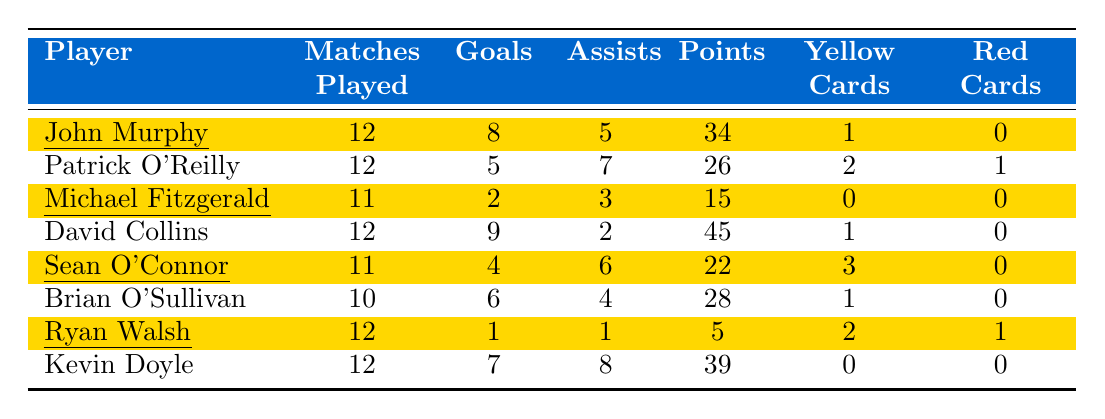What is the total number of goals scored by John Murphy? John Murphy scored 8 goals during the season, as indicated in the table under the "Goals" column for his row.
Answer: 8 Who has the highest number of points among the players? David Collins has the highest number of points with a total of 45, which is the maximum value in the "Points" column.
Answer: 45 How many players received a red card? There are two players (Patrick O'Reilly and Ryan Walsh) who received red cards, as noted in their respective rows in the "Red Cards" column.
Answer: 2 What is the average number of assists for all players? To find the average, sum the assists (5 + 7 + 3 + 2 + 6 + 4 + 1 + 8) = 36, and divide by the number of players (8). 36/8 = 4.5.
Answer: 4.5 Did any players have no yellow cards? Yes, Michael Fitzgerald and Kevin Doyle did not receive any yellow cards, as their rows show '0' under the "Yellow Cards" column.
Answer: Yes Which player played the least number of matches? Brian O'Sullivan played the least number of matches with a total of 10, according to the "Matches Played" column.
Answer: 10 What is the total number of goals scored by players who played more than 11 matches? Players who played more than 11 matches are John Murphy, Patrick O'Reilly, David Collins, and Kevin Doyle, contributing (8 + 5 + 9 + 7) = 29 goals.
Answer: 29 Is it true that Sean O'Connor got more assists than goals? Yes, Sean O'Connor has 6 assists and 4 goals, confirming that assists exceed goals for him.
Answer: Yes What is the difference in the number of points between John Murphy and Kevin Doyle? John Murphy has 34 points and Kevin Doyle has 39 points. The difference is 39 - 34 = 5.
Answer: 5 Among players who received yellow cards, who scored the most goals? From the players who received yellow cards, David Collins scored the most goals (9) compared to John Murphy (8), Patrick O'Reilly (5), Sean O'Connor (4), and Ryan Walsh (1).
Answer: David Collins 